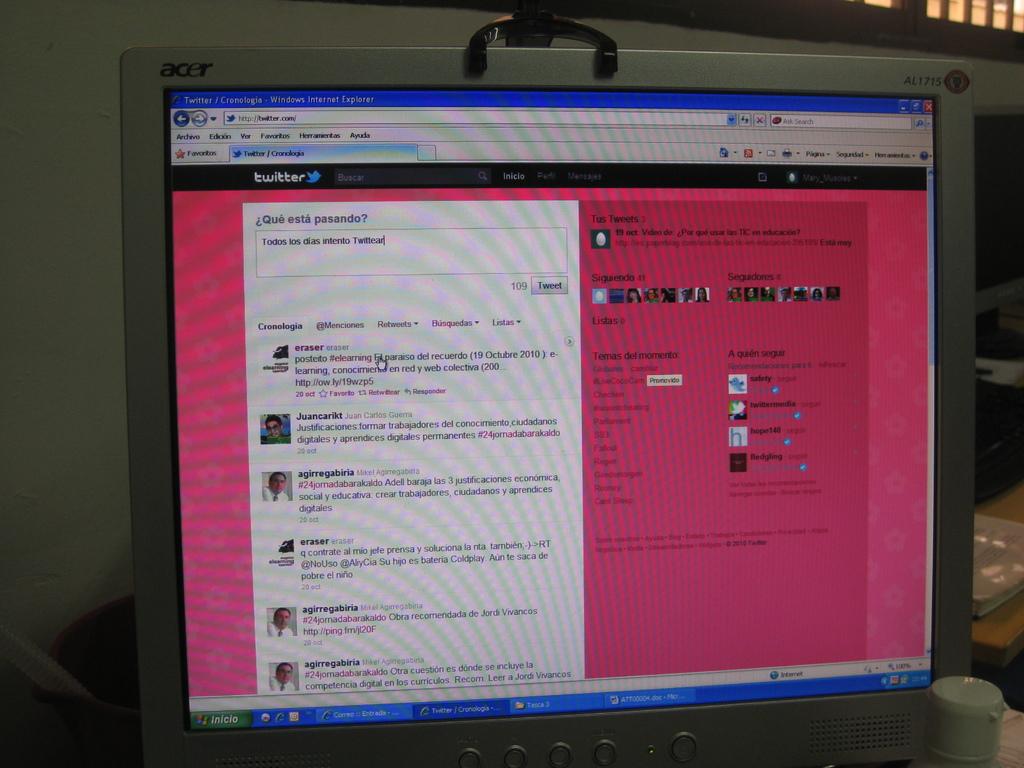What social media site is this page?
Make the answer very short. Twitter. What is the computer brand?
Offer a terse response. Acer. 